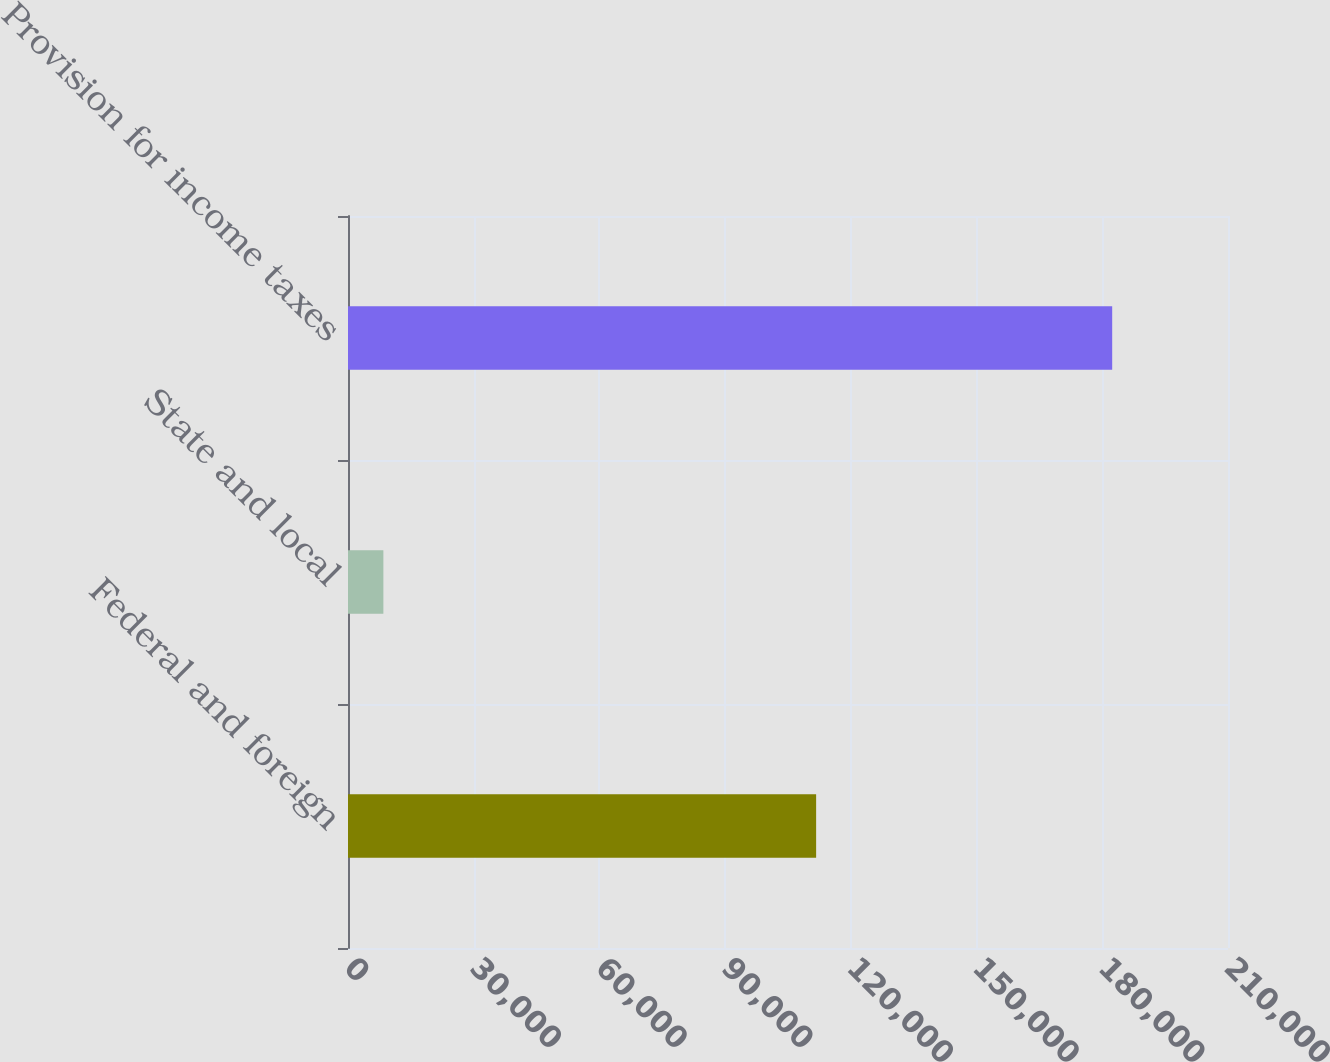<chart> <loc_0><loc_0><loc_500><loc_500><bar_chart><fcel>Federal and foreign<fcel>State and local<fcel>Provision for income taxes<nl><fcel>111713<fcel>8442<fcel>182363<nl></chart> 